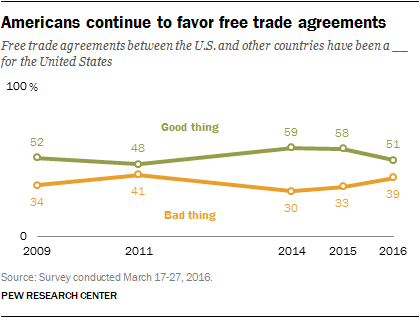List a handful of essential elements in this visual. The average percentage value of the green line from 2014 to 2016 was 56%. The peak of the good thing line was reached in 2014. 